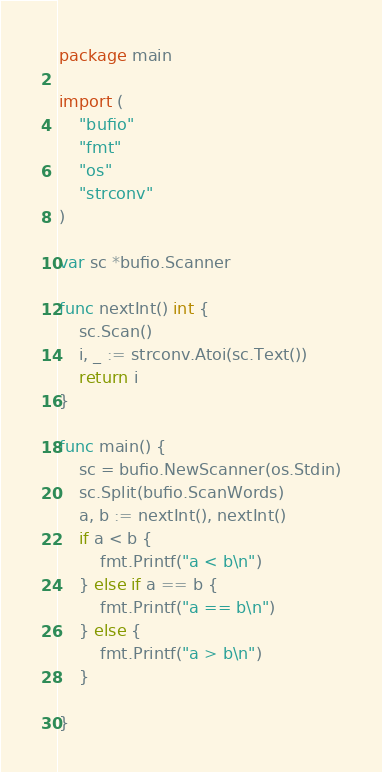<code> <loc_0><loc_0><loc_500><loc_500><_Go_>package main

import (
	"bufio"
	"fmt"
	"os"
	"strconv"
)

var sc *bufio.Scanner

func nextInt() int {
	sc.Scan()
	i, _ := strconv.Atoi(sc.Text())
	return i
}

func main() {
	sc = bufio.NewScanner(os.Stdin)
	sc.Split(bufio.ScanWords)
	a, b := nextInt(), nextInt()
	if a < b {
		fmt.Printf("a < b\n")
	} else if a == b {
		fmt.Printf("a == b\n")
	} else {
		fmt.Printf("a > b\n")
	}

}

</code> 